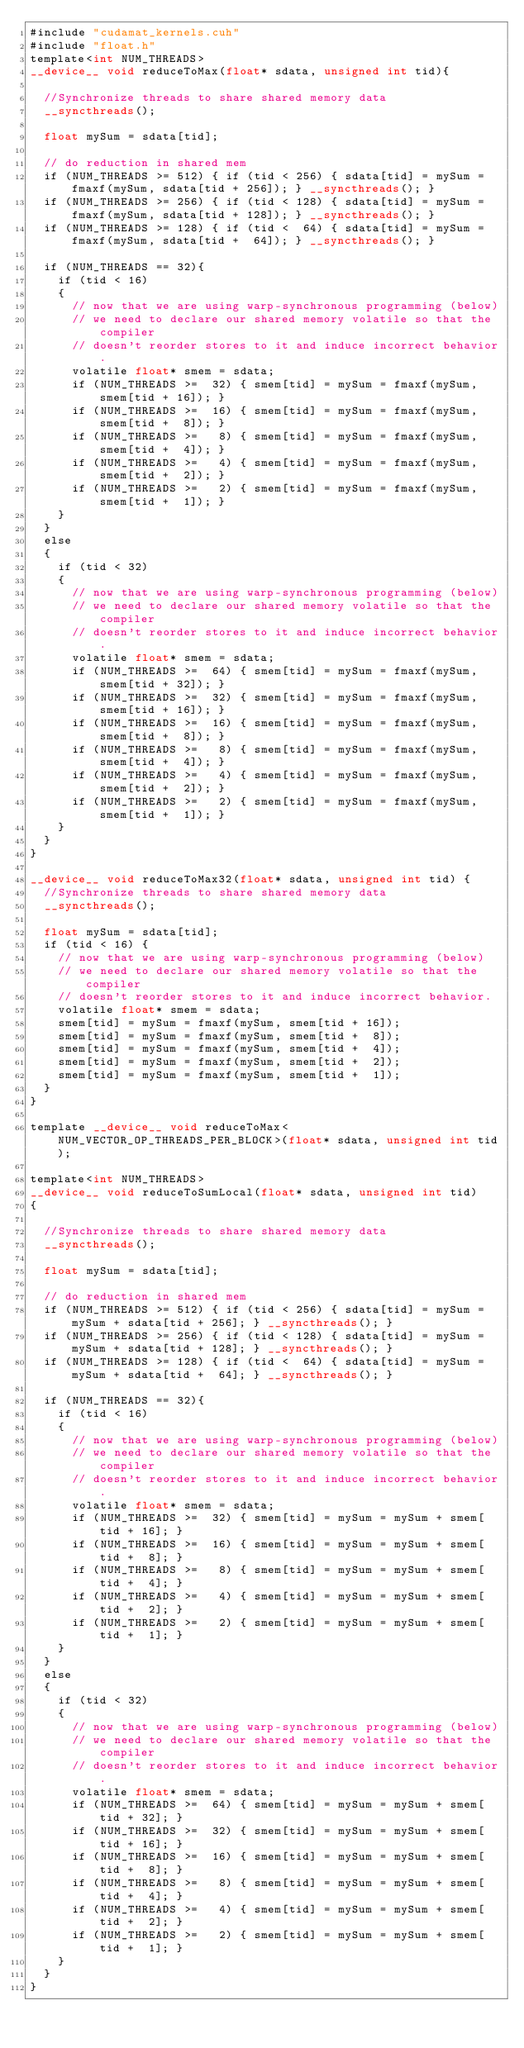Convert code to text. <code><loc_0><loc_0><loc_500><loc_500><_Cuda_>#include "cudamat_kernels.cuh"
#include "float.h"
template<int NUM_THREADS>
__device__ void reduceToMax(float* sdata, unsigned int tid){

  //Synchronize threads to share shared memory data
  __syncthreads();

  float mySum = sdata[tid];

  // do reduction in shared mem
  if (NUM_THREADS >= 512) { if (tid < 256) { sdata[tid] = mySum = fmaxf(mySum, sdata[tid + 256]); } __syncthreads(); }
  if (NUM_THREADS >= 256) { if (tid < 128) { sdata[tid] = mySum = fmaxf(mySum, sdata[tid + 128]); } __syncthreads(); }
  if (NUM_THREADS >= 128) { if (tid <  64) { sdata[tid] = mySum = fmaxf(mySum, sdata[tid +  64]); } __syncthreads(); }

  if (NUM_THREADS == 32){
    if (tid < 16)
    {
      // now that we are using warp-synchronous programming (below)
      // we need to declare our shared memory volatile so that the compiler
      // doesn't reorder stores to it and induce incorrect behavior.
      volatile float* smem = sdata;
      if (NUM_THREADS >=  32) { smem[tid] = mySum = fmaxf(mySum, smem[tid + 16]); }
      if (NUM_THREADS >=  16) { smem[tid] = mySum = fmaxf(mySum, smem[tid +  8]); }
      if (NUM_THREADS >=   8) { smem[tid] = mySum = fmaxf(mySum, smem[tid +  4]); }
      if (NUM_THREADS >=   4) { smem[tid] = mySum = fmaxf(mySum, smem[tid +  2]); }
      if (NUM_THREADS >=   2) { smem[tid] = mySum = fmaxf(mySum, smem[tid +  1]); }
    }
  }
  else
  {
    if (tid < 32)
    {
      // now that we are using warp-synchronous programming (below)
      // we need to declare our shared memory volatile so that the compiler
      // doesn't reorder stores to it and induce incorrect behavior.
      volatile float* smem = sdata;
      if (NUM_THREADS >=  64) { smem[tid] = mySum = fmaxf(mySum, smem[tid + 32]); }
      if (NUM_THREADS >=  32) { smem[tid] = mySum = fmaxf(mySum, smem[tid + 16]); }
      if (NUM_THREADS >=  16) { smem[tid] = mySum = fmaxf(mySum, smem[tid +  8]); }
      if (NUM_THREADS >=   8) { smem[tid] = mySum = fmaxf(mySum, smem[tid +  4]); }
      if (NUM_THREADS >=   4) { smem[tid] = mySum = fmaxf(mySum, smem[tid +  2]); }
      if (NUM_THREADS >=   2) { smem[tid] = mySum = fmaxf(mySum, smem[tid +  1]); }
    }
  }
}

__device__ void reduceToMax32(float* sdata, unsigned int tid) {
  //Synchronize threads to share shared memory data
  __syncthreads();

  float mySum = sdata[tid];
  if (tid < 16) {
    // now that we are using warp-synchronous programming (below)
    // we need to declare our shared memory volatile so that the compiler
    // doesn't reorder stores to it and induce incorrect behavior.
    volatile float* smem = sdata;
    smem[tid] = mySum = fmaxf(mySum, smem[tid + 16]);
    smem[tid] = mySum = fmaxf(mySum, smem[tid +  8]);
    smem[tid] = mySum = fmaxf(mySum, smem[tid +  4]);
    smem[tid] = mySum = fmaxf(mySum, smem[tid +  2]);
    smem[tid] = mySum = fmaxf(mySum, smem[tid +  1]);
  }
}

template __device__ void reduceToMax<NUM_VECTOR_OP_THREADS_PER_BLOCK>(float* sdata, unsigned int tid);

template<int NUM_THREADS>
__device__ void reduceToSumLocal(float* sdata, unsigned int tid)
{

  //Synchronize threads to share shared memory data
  __syncthreads();

  float mySum = sdata[tid];

  // do reduction in shared mem
  if (NUM_THREADS >= 512) { if (tid < 256) { sdata[tid] = mySum = mySum + sdata[tid + 256]; } __syncthreads(); }
  if (NUM_THREADS >= 256) { if (tid < 128) { sdata[tid] = mySum = mySum + sdata[tid + 128]; } __syncthreads(); }
  if (NUM_THREADS >= 128) { if (tid <  64) { sdata[tid] = mySum = mySum + sdata[tid +  64]; } __syncthreads(); }

  if (NUM_THREADS == 32){
    if (tid < 16)
    {
      // now that we are using warp-synchronous programming (below)
      // we need to declare our shared memory volatile so that the compiler
      // doesn't reorder stores to it and induce incorrect behavior.
      volatile float* smem = sdata;
      if (NUM_THREADS >=  32) { smem[tid] = mySum = mySum + smem[tid + 16]; }
      if (NUM_THREADS >=  16) { smem[tid] = mySum = mySum + smem[tid +  8]; }
      if (NUM_THREADS >=   8) { smem[tid] = mySum = mySum + smem[tid +  4]; }
      if (NUM_THREADS >=   4) { smem[tid] = mySum = mySum + smem[tid +  2]; }
      if (NUM_THREADS >=   2) { smem[tid] = mySum = mySum + smem[tid +  1]; }
    }
  }
  else
  {
    if (tid < 32)
    {
      // now that we are using warp-synchronous programming (below)
      // we need to declare our shared memory volatile so that the compiler
      // doesn't reorder stores to it and induce incorrect behavior.
      volatile float* smem = sdata;
      if (NUM_THREADS >=  64) { smem[tid] = mySum = mySum + smem[tid + 32]; }
      if (NUM_THREADS >=  32) { smem[tid] = mySum = mySum + smem[tid + 16]; }
      if (NUM_THREADS >=  16) { smem[tid] = mySum = mySum + smem[tid +  8]; }
      if (NUM_THREADS >=   8) { smem[tid] = mySum = mySum + smem[tid +  4]; }
      if (NUM_THREADS >=   4) { smem[tid] = mySum = mySum + smem[tid +  2]; }
      if (NUM_THREADS >=   2) { smem[tid] = mySum = mySum + smem[tid +  1]; }
    }
  }
}</code> 